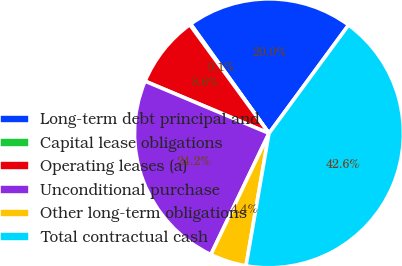<chart> <loc_0><loc_0><loc_500><loc_500><pie_chart><fcel>Long-term debt principal and<fcel>Capital lease obligations<fcel>Operating leases (a)<fcel>Unconditional purchase<fcel>Other long-term obligations<fcel>Total contractual cash<nl><fcel>19.98%<fcel>0.13%<fcel>8.63%<fcel>24.23%<fcel>4.38%<fcel>42.64%<nl></chart> 